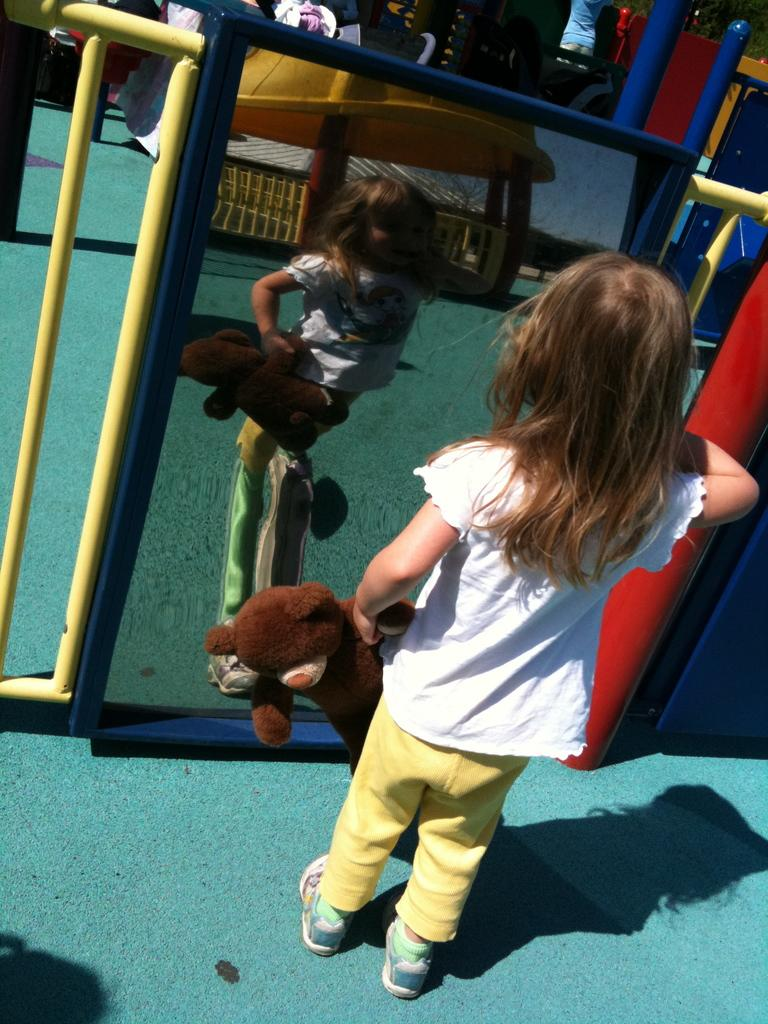Who is the main subject in the image? There is a girl in the image. What is the girl standing on? The girl is standing on a mat. What object is the girl holding? The girl is holding a teddy bear. What can be seen in front of the girl? There is a mirror in front of the girl. What type of hat is the girl wearing in the image? The girl is not wearing a hat in the image. 